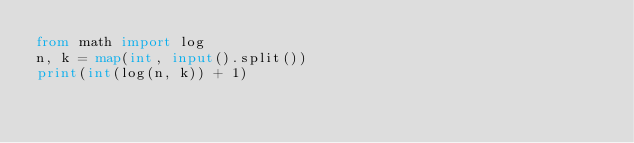<code> <loc_0><loc_0><loc_500><loc_500><_Python_>from math import log
n, k = map(int, input().split())
print(int(log(n, k)) + 1)</code> 